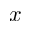Convert formula to latex. <formula><loc_0><loc_0><loc_500><loc_500>x</formula> 